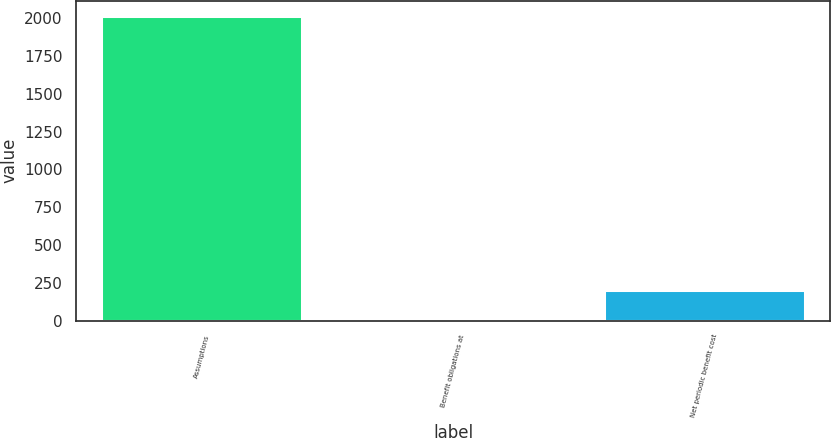<chart> <loc_0><loc_0><loc_500><loc_500><bar_chart><fcel>Assumptions<fcel>Benefit obligations at<fcel>Net periodic benefit cost<nl><fcel>2015<fcel>3.5<fcel>204.65<nl></chart> 